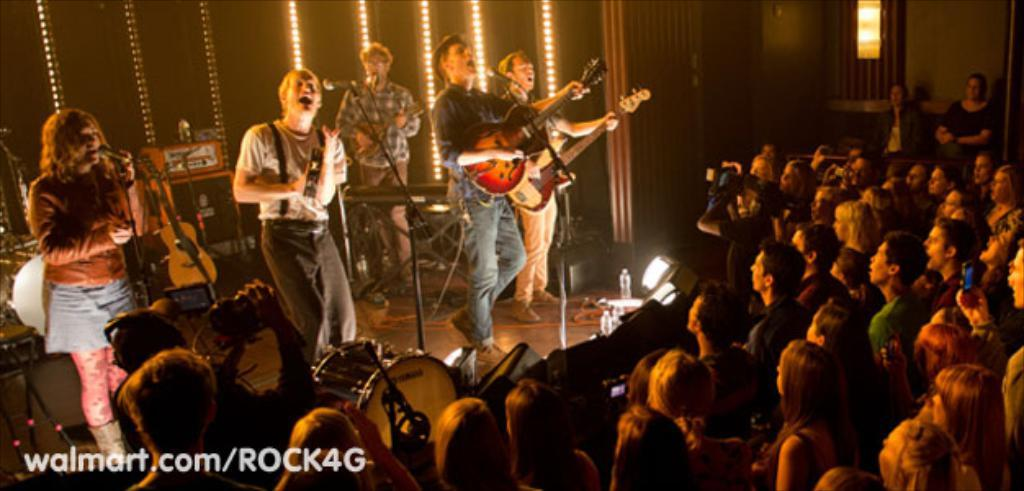What are the people in the image doing? The people in the image are singing and playing guitar. What object can be seen in front of the group of people? They are in front of a microphone. Are there any other people visible in the image? Yes, there is another group of people standing on the right side of the image. What type of quilt is being used as a cushion by the people in the image? There is no quilt or cushion present in the image; the people are standing or sitting while singing and playing guitar. 